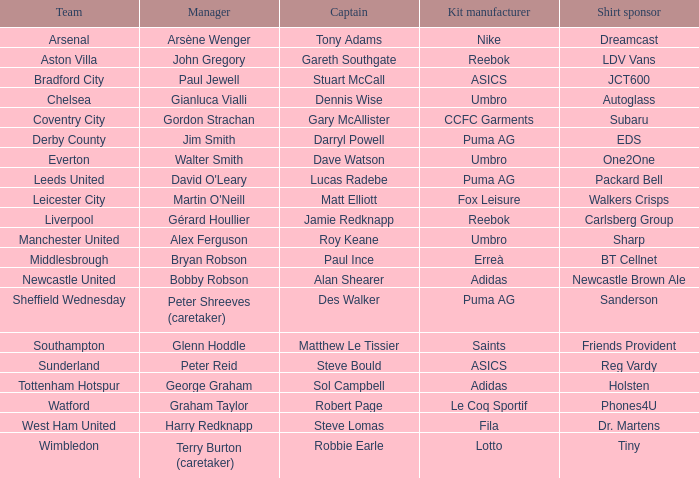Which shirt sponsor is associated with nike as their kit manufacturer? Dreamcast. 